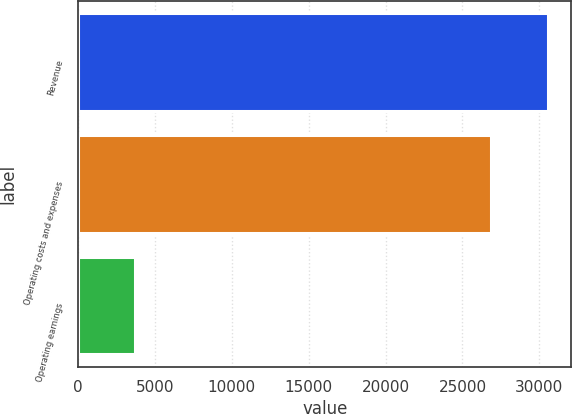Convert chart. <chart><loc_0><loc_0><loc_500><loc_500><bar_chart><fcel>Revenue<fcel>Operating costs and expenses<fcel>Operating earnings<nl><fcel>30561<fcel>26827<fcel>3734<nl></chart> 